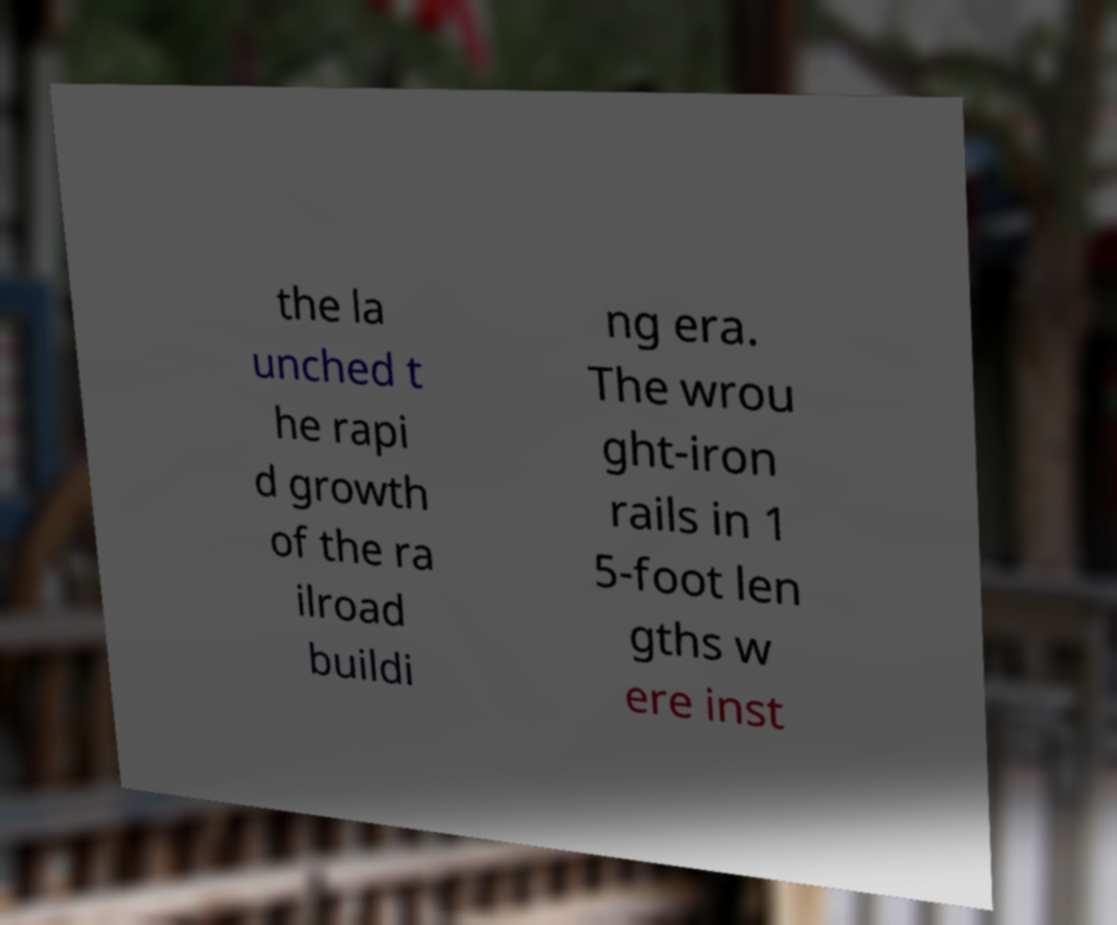Could you assist in decoding the text presented in this image and type it out clearly? the la unched t he rapi d growth of the ra ilroad buildi ng era. The wrou ght-iron rails in 1 5-foot len gths w ere inst 